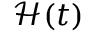Convert formula to latex. <formula><loc_0><loc_0><loc_500><loc_500>\mathcal { H } ( t )</formula> 